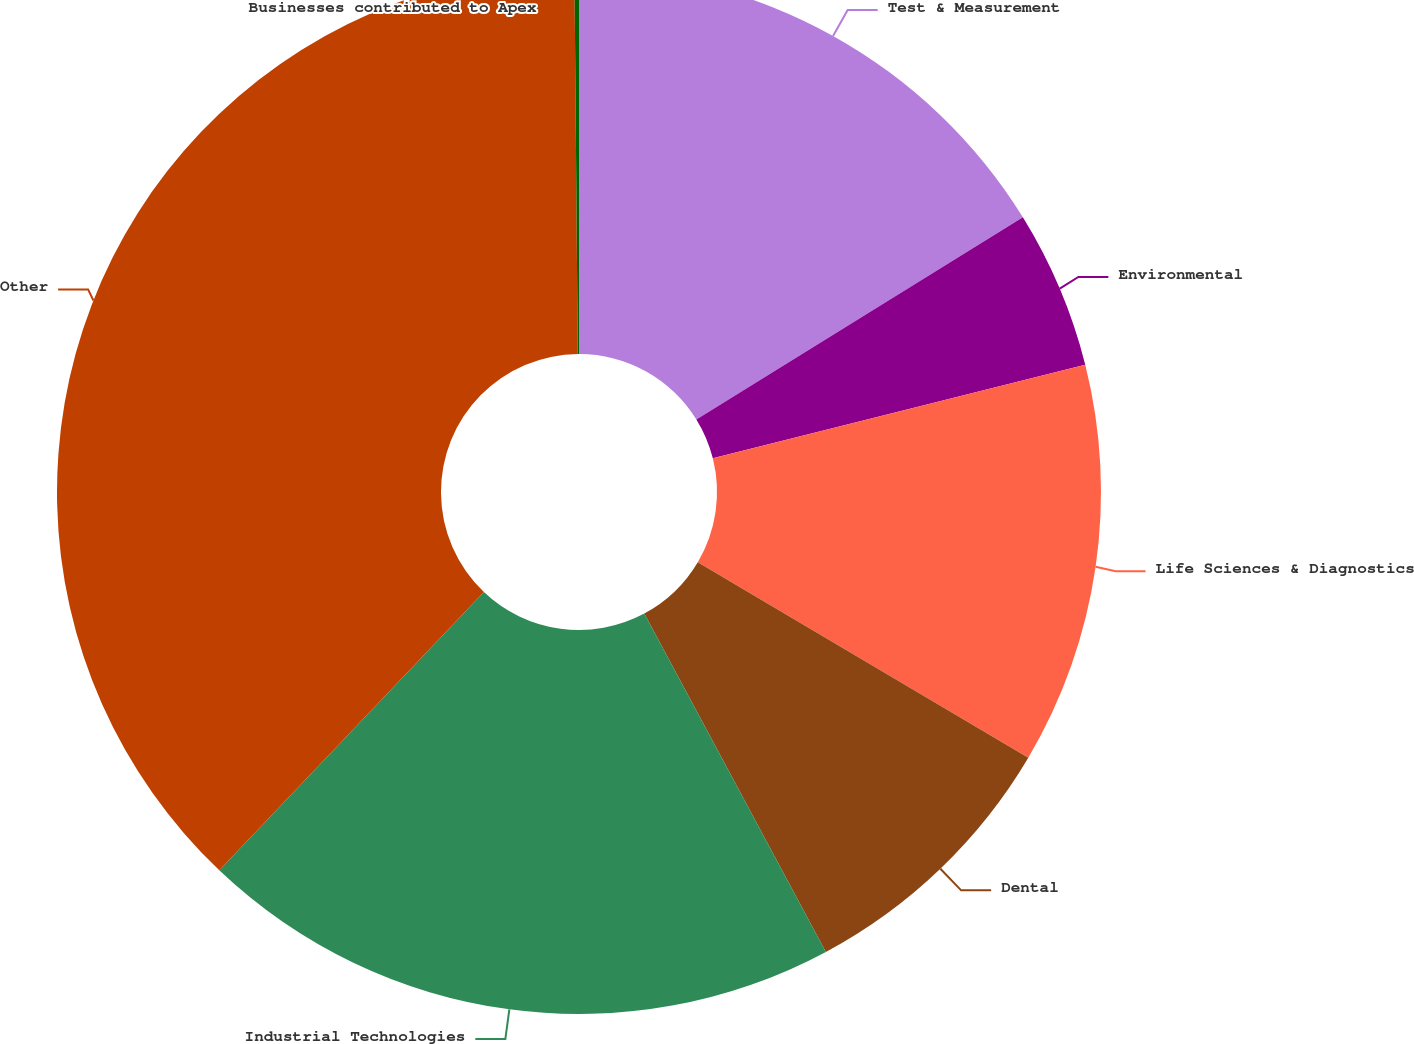<chart> <loc_0><loc_0><loc_500><loc_500><pie_chart><fcel>Test & Measurement<fcel>Environmental<fcel>Life Sciences & Diagnostics<fcel>Dental<fcel>Industrial Technologies<fcel>Other<fcel>Businesses contributed to Apex<nl><fcel>16.18%<fcel>4.9%<fcel>12.42%<fcel>8.66%<fcel>19.94%<fcel>37.76%<fcel>0.14%<nl></chart> 